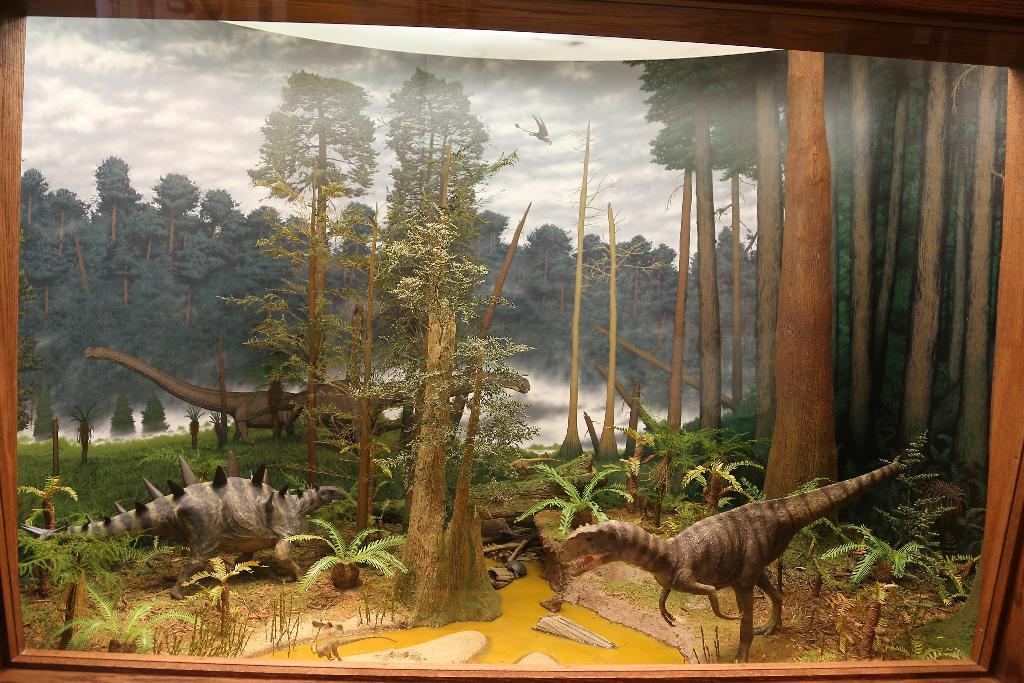What type of frame is visible in the image? There is a wooden frame in the image. What is depicted in the art within the frame? The art features dinosaurs, plants, trees, and a flying dinosaur. How is the sky depicted in the background of the image? The sky in the background of the image is cloudy. What type of wine is being served in the yard in the image? There is no wine or yard present in the image; it features a wooden frame with art depicting dinosaurs, plants, trees, and a flying dinosaur against a cloudy sky. 